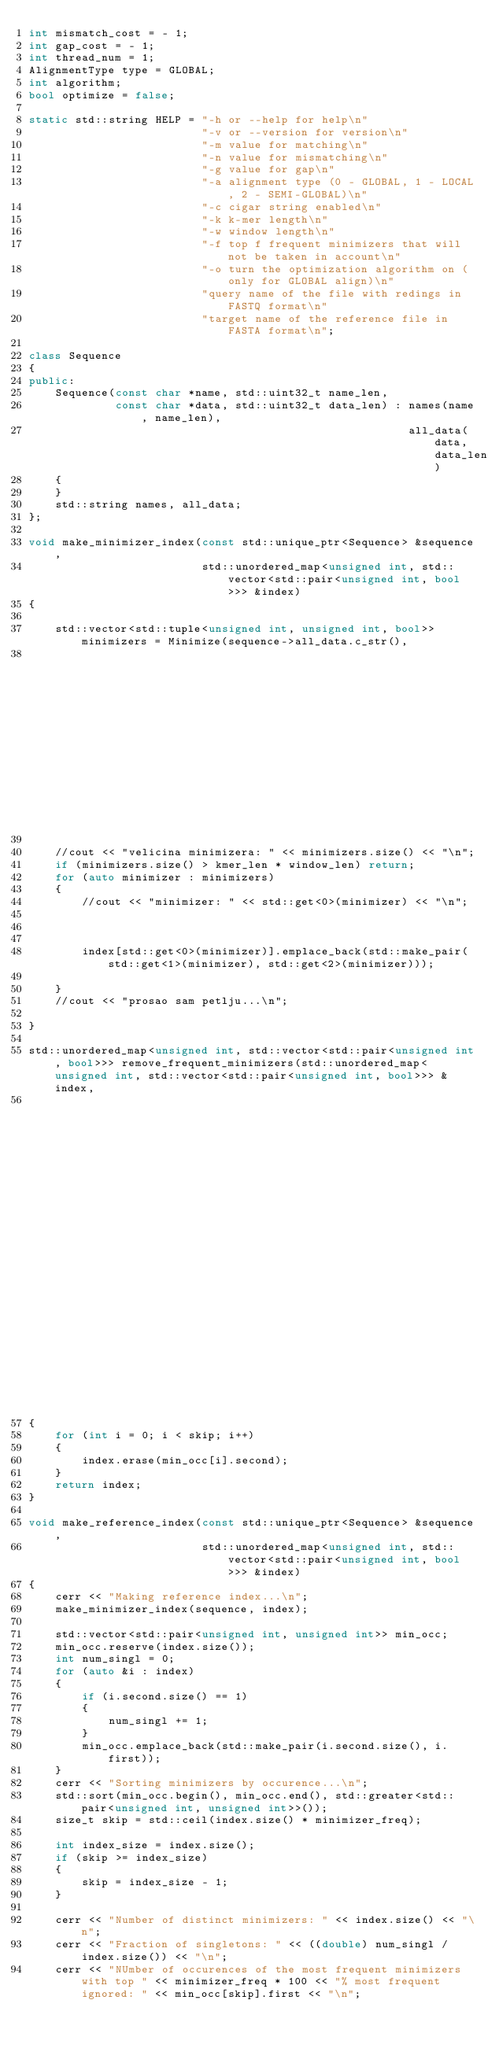Convert code to text. <code><loc_0><loc_0><loc_500><loc_500><_C++_>int mismatch_cost = - 1;
int gap_cost = - 1;
int thread_num = 1;
AlignmentType type = GLOBAL;
int algorithm;
bool optimize = false;

static std::string HELP = "-h or --help for help\n"
                          "-v or --version for version\n"
                          "-m value for matching\n"
                          "-n value for mismatching\n"
                          "-g value for gap\n"
                          "-a alignment type (0 - GLOBAL, 1 - LOCAL, 2 - SEMI-GLOBAL)\n"
                          "-c cigar string enabled\n"
                          "-k k-mer length\n"
                          "-w window length\n"
                          "-f top f frequent minimizers that will not be taken in account\n"
                          "-o turn the optimization algorithm on (only for GLOBAL align)\n"
                          "query name of the file with redings in FASTQ format\n"
                          "target name of the reference file in FASTA format\n";

class Sequence
{
public:
    Sequence(const char *name, std::uint32_t name_len,
             const char *data, std::uint32_t data_len) : names(name, name_len),
                                                         all_data(data, data_len)
    {
    }
    std::string names, all_data;
};

void make_minimizer_index(const std::unique_ptr<Sequence> &sequence,
                          std::unordered_map<unsigned int, std::vector<std::pair<unsigned int, bool>>> &index)
{
    
    std::vector<std::tuple<unsigned int, unsigned int, bool>> minimizers = Minimize(sequence->all_data.c_str(),
                                                                                    sequence->all_data.size(), kmer_len, window_len);
    
    //cout << "velicina minimizera: " << minimizers.size() << "\n";
    if (minimizers.size() > kmer_len * window_len) return;
    for (auto minimizer : minimizers)
    {
        //cout << "minimizer: " << std::get<0>(minimizer) << "\n";
        


        index[std::get<0>(minimizer)].emplace_back(std::make_pair(std::get<1>(minimizer), std::get<2>(minimizer)));
        
    }
    //cout << "prosao sam petlju...\n";
    
}

std::unordered_map<unsigned int, std::vector<std::pair<unsigned int, bool>>> remove_frequent_minimizers(std::unordered_map<unsigned int, std::vector<std::pair<unsigned int, bool>>> &index,
                                                                                                        int skip, std::vector<std::pair<unsigned int, unsigned int>> min_occ)
{
    for (int i = 0; i < skip; i++)
    {
        index.erase(min_occ[i].second);
    }
    return index;
}

void make_reference_index(const std::unique_ptr<Sequence> &sequence,
                          std::unordered_map<unsigned int, std::vector<std::pair<unsigned int, bool>>> &index)
{
    cerr << "Making reference index...\n"; 
    make_minimizer_index(sequence, index);
    
    std::vector<std::pair<unsigned int, unsigned int>> min_occ;
    min_occ.reserve(index.size());
    int num_singl = 0;
    for (auto &i : index)
    {
        if (i.second.size() == 1)
        {
            num_singl += 1;
        }
        min_occ.emplace_back(std::make_pair(i.second.size(), i.first));
    }
    cerr << "Sorting minimizers by occurence...\n";
    std::sort(min_occ.begin(), min_occ.end(), std::greater<std::pair<unsigned int, unsigned int>>());
    size_t skip = std::ceil(index.size() * minimizer_freq);

    int index_size = index.size();
    if (skip >= index_size)
    {
        skip = index_size - 1;
    }

    cerr << "Number of distinct minimizers: " << index.size() << "\n";
    cerr << "Fraction of singletons: " << ((double) num_singl / index.size()) << "\n"; 
    cerr << "NUmber of occurences of the most frequent minimizers with top " << minimizer_freq * 100 << "% most frequent ignored: " << min_occ[skip].first << "\n";
</code> 